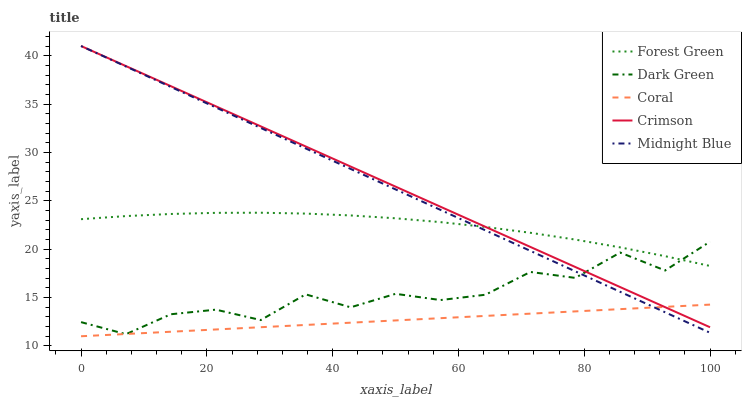Does Coral have the minimum area under the curve?
Answer yes or no. Yes. Does Crimson have the maximum area under the curve?
Answer yes or no. Yes. Does Forest Green have the minimum area under the curve?
Answer yes or no. No. Does Forest Green have the maximum area under the curve?
Answer yes or no. No. Is Coral the smoothest?
Answer yes or no. Yes. Is Dark Green the roughest?
Answer yes or no. Yes. Is Forest Green the smoothest?
Answer yes or no. No. Is Forest Green the roughest?
Answer yes or no. No. Does Coral have the lowest value?
Answer yes or no. Yes. Does Midnight Blue have the lowest value?
Answer yes or no. No. Does Midnight Blue have the highest value?
Answer yes or no. Yes. Does Forest Green have the highest value?
Answer yes or no. No. Is Coral less than Forest Green?
Answer yes or no. Yes. Is Forest Green greater than Coral?
Answer yes or no. Yes. Does Midnight Blue intersect Forest Green?
Answer yes or no. Yes. Is Midnight Blue less than Forest Green?
Answer yes or no. No. Is Midnight Blue greater than Forest Green?
Answer yes or no. No. Does Coral intersect Forest Green?
Answer yes or no. No. 